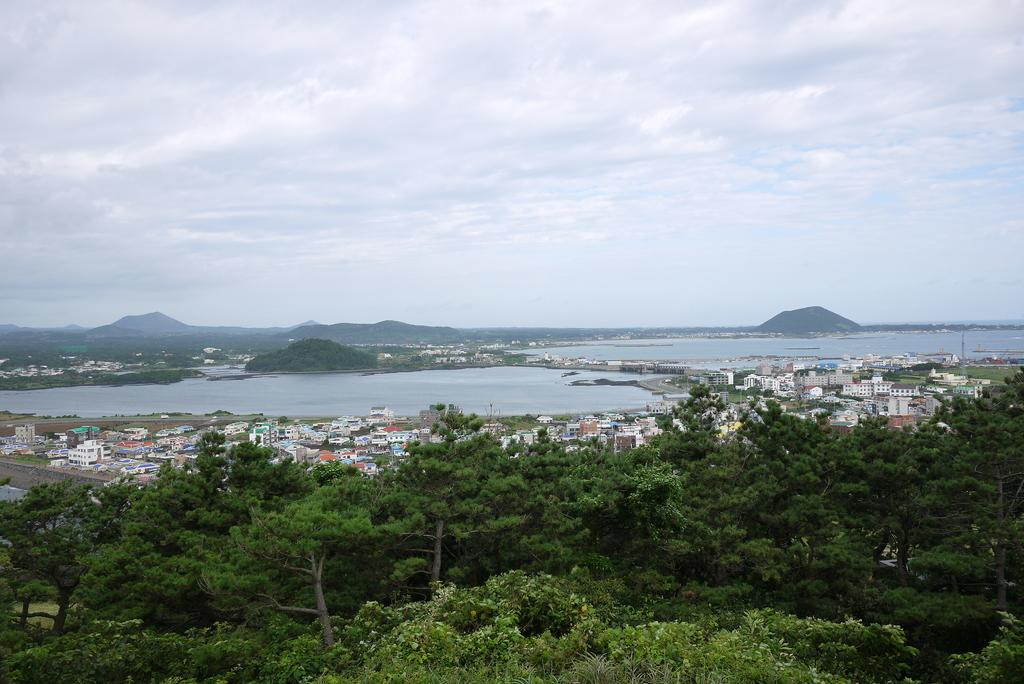What type of vegetation is at the bottom of the image? There are trees at the bottom of the image. What structures are located in the middle of the image? There are buildings in the middle of the image. What body of water is present in the image? It appears to be a river in the image. What is visible at the top of the image? The sky is visible at the top of the image. Can you see any arms or noses in the image? There are no arms or noses present in the image. What type of jar is visible in the image? There is no jar present in the image. 